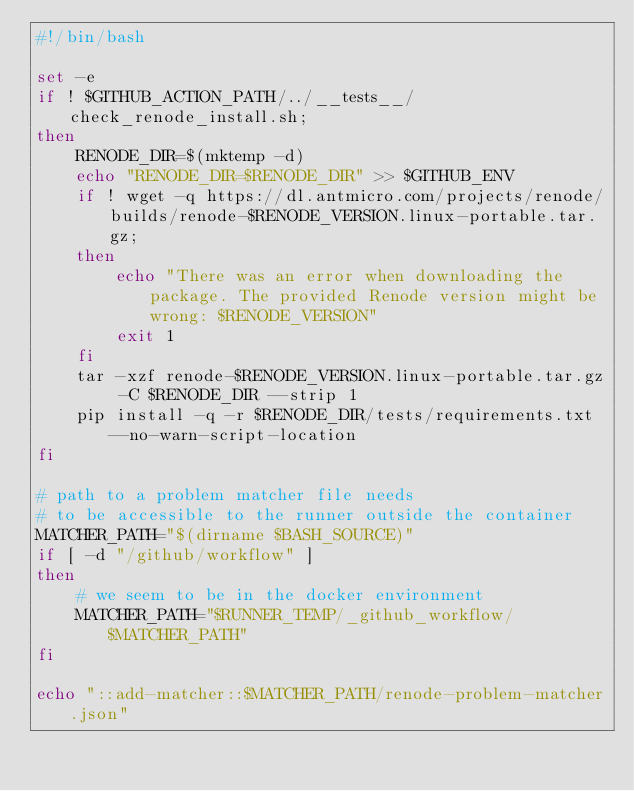Convert code to text. <code><loc_0><loc_0><loc_500><loc_500><_Bash_>#!/bin/bash

set -e
if ! $GITHUB_ACTION_PATH/../__tests__/check_renode_install.sh;
then
    RENODE_DIR=$(mktemp -d)
    echo "RENODE_DIR=$RENODE_DIR" >> $GITHUB_ENV
    if ! wget -q https://dl.antmicro.com/projects/renode/builds/renode-$RENODE_VERSION.linux-portable.tar.gz;
    then
        echo "There was an error when downloading the package. The provided Renode version might be wrong: $RENODE_VERSION"
        exit 1
    fi
    tar -xzf renode-$RENODE_VERSION.linux-portable.tar.gz -C $RENODE_DIR --strip 1
    pip install -q -r $RENODE_DIR/tests/requirements.txt --no-warn-script-location
fi

# path to a problem matcher file needs
# to be accessible to the runner outside the container
MATCHER_PATH="$(dirname $BASH_SOURCE)"
if [ -d "/github/workflow" ]
then
    # we seem to be in the docker environment
    MATCHER_PATH="$RUNNER_TEMP/_github_workflow/$MATCHER_PATH"
fi

echo "::add-matcher::$MATCHER_PATH/renode-problem-matcher.json"
</code> 